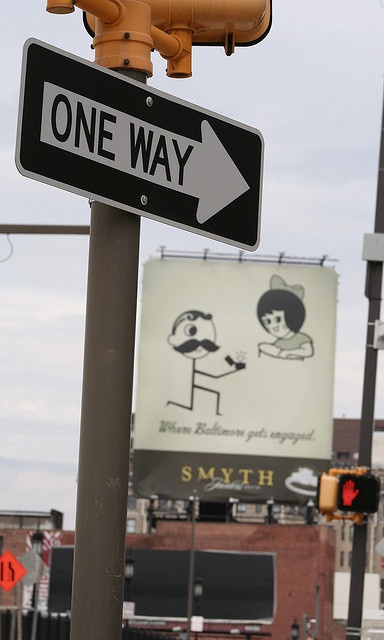Describe the objects in this image and their specific colors. I can see traffic light in lavender, brown, maroon, and black tones, stop sign in lavender, black, brown, and maroon tones, and people in lavender, black, gray, and maroon tones in this image. 